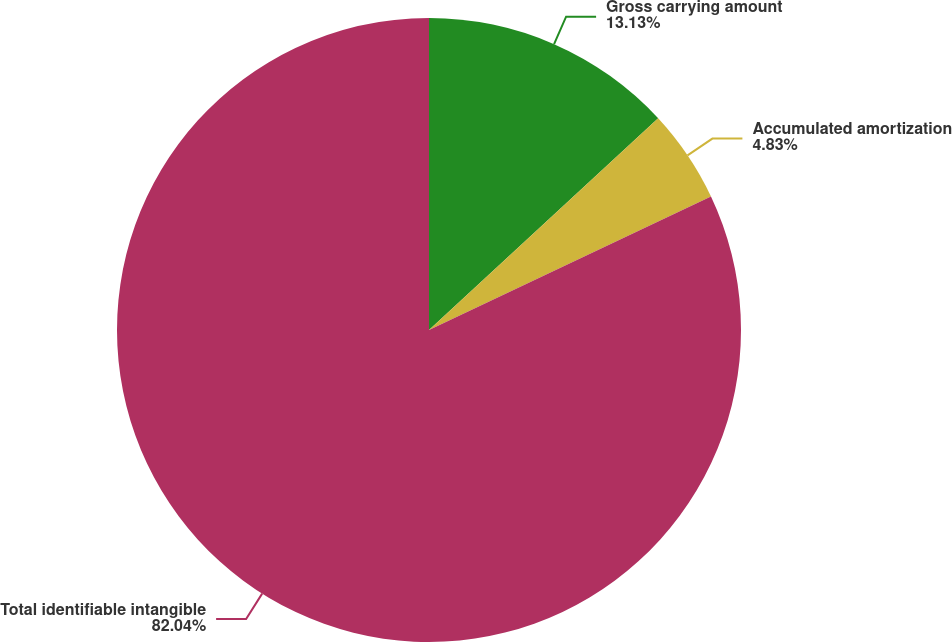Convert chart. <chart><loc_0><loc_0><loc_500><loc_500><pie_chart><fcel>Gross carrying amount<fcel>Accumulated amortization<fcel>Total identifiable intangible<nl><fcel>13.13%<fcel>4.83%<fcel>82.04%<nl></chart> 